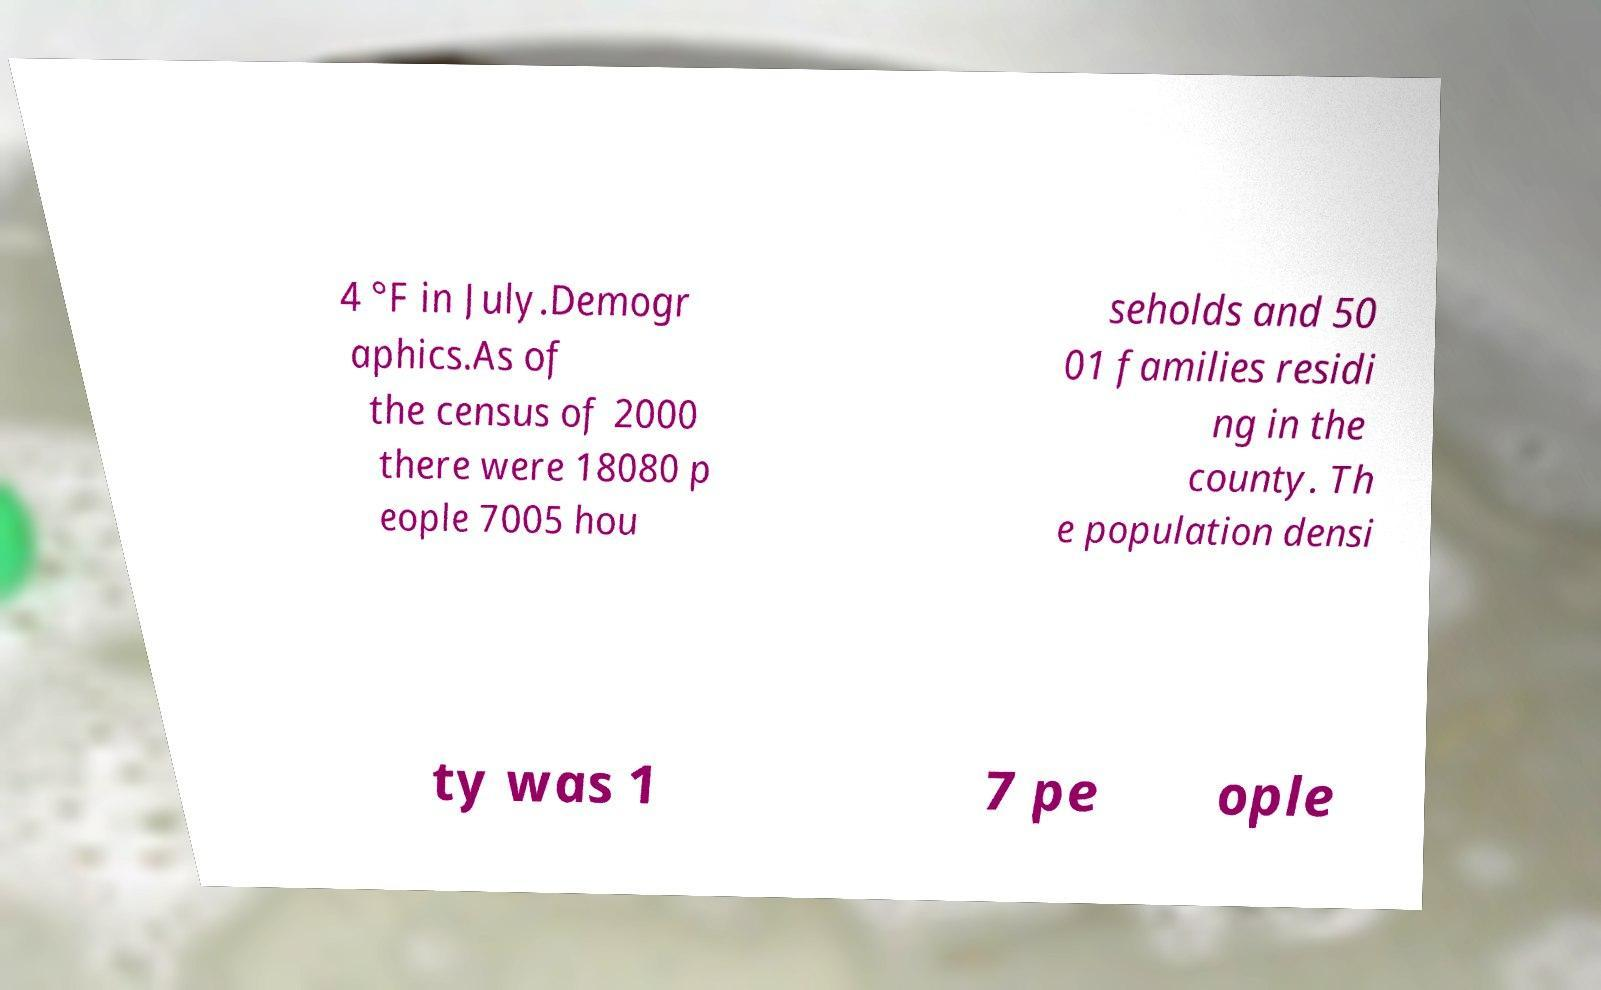Can you accurately transcribe the text from the provided image for me? 4 °F in July.Demogr aphics.As of the census of 2000 there were 18080 p eople 7005 hou seholds and 50 01 families residi ng in the county. Th e population densi ty was 1 7 pe ople 